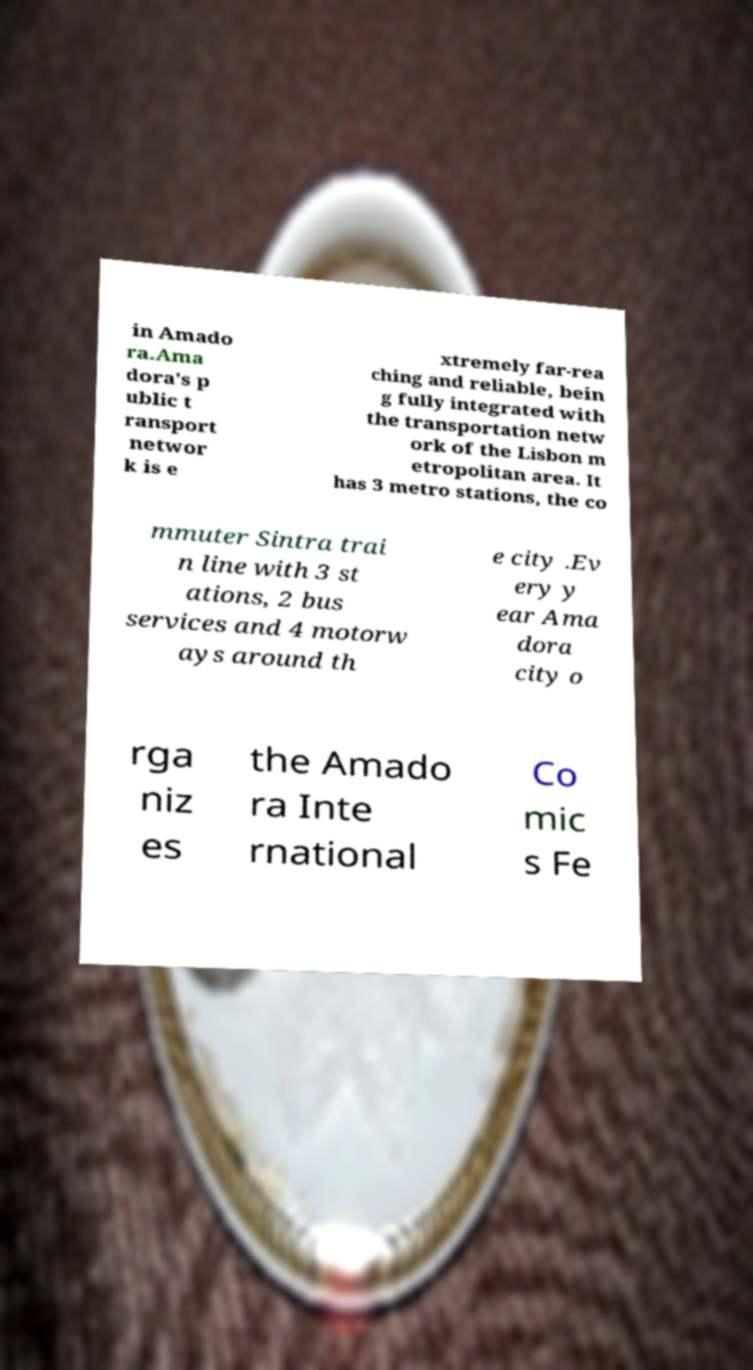Could you extract and type out the text from this image? in Amado ra.Ama dora's p ublic t ransport networ k is e xtremely far-rea ching and reliable, bein g fully integrated with the transportation netw ork of the Lisbon m etropolitan area. It has 3 metro stations, the co mmuter Sintra trai n line with 3 st ations, 2 bus services and 4 motorw ays around th e city .Ev ery y ear Ama dora city o rga niz es the Amado ra Inte rnational Co mic s Fe 